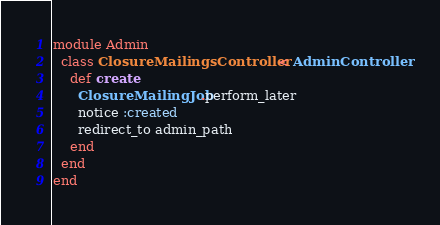<code> <loc_0><loc_0><loc_500><loc_500><_Ruby_>module Admin
  class ClosureMailingsController < AdminController
    def create
      ClosureMailingJob.perform_later
      notice :created
      redirect_to admin_path
    end
  end
end
</code> 